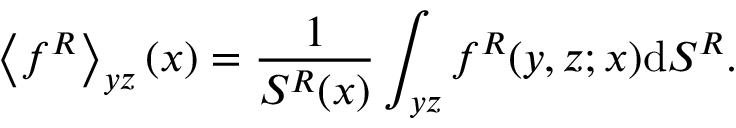<formula> <loc_0><loc_0><loc_500><loc_500>\left \langle f ^ { R } \right \rangle _ { y z } ( x ) = \frac { 1 } { S ^ { R } ( x ) } \int _ { y z } f ^ { R } ( y , z ; x ) d S ^ { R } .</formula> 